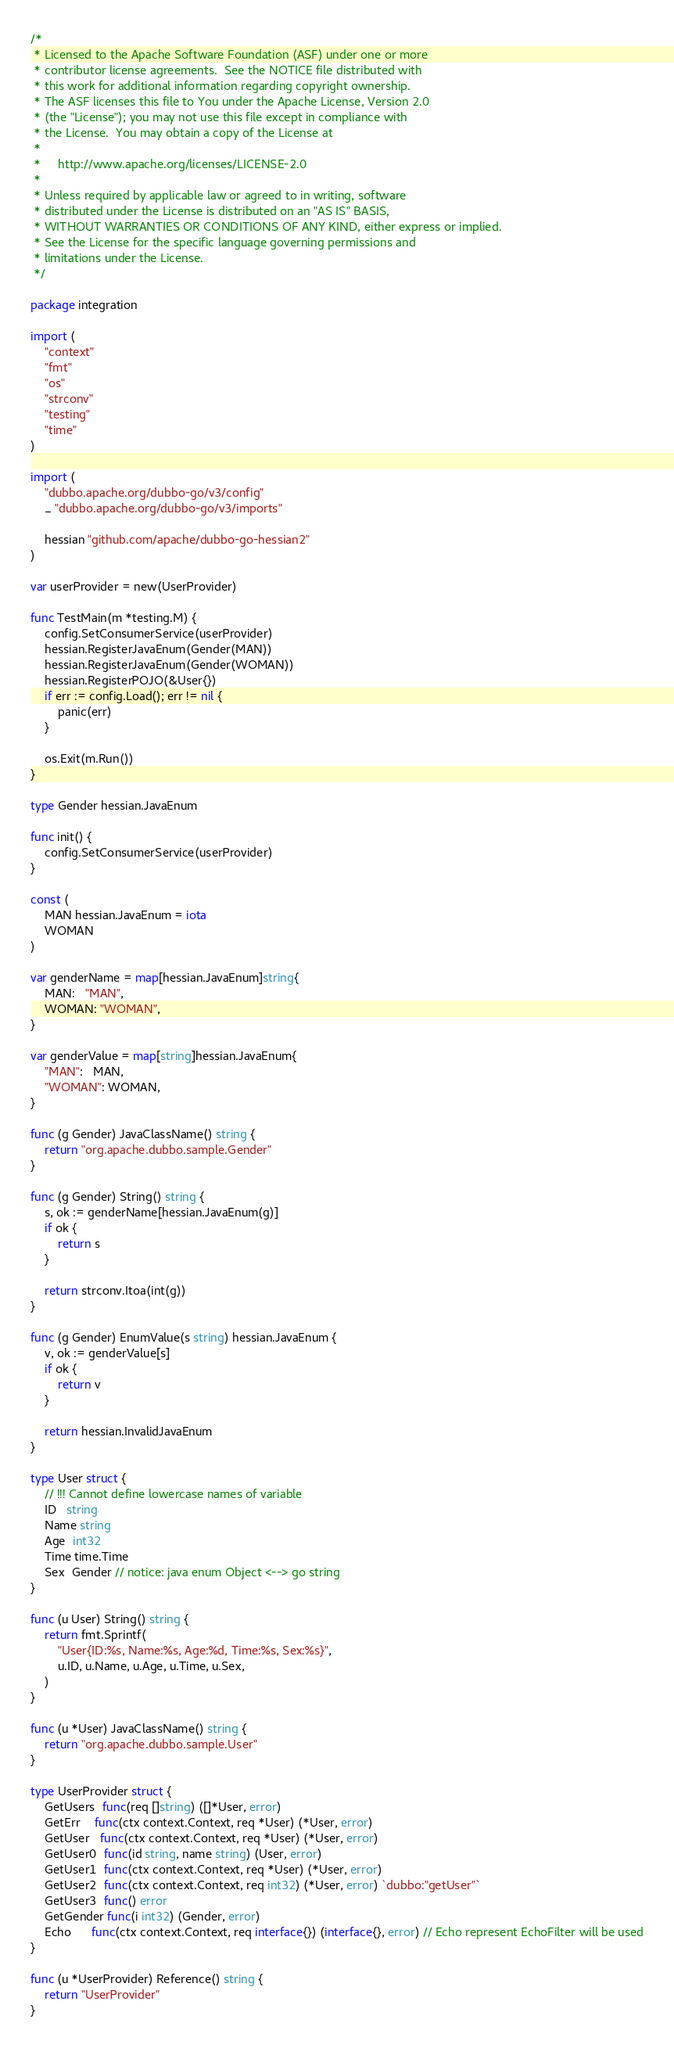Convert code to text. <code><loc_0><loc_0><loc_500><loc_500><_Go_>/*
 * Licensed to the Apache Software Foundation (ASF) under one or more
 * contributor license agreements.  See the NOTICE file distributed with
 * this work for additional information regarding copyright ownership.
 * The ASF licenses this file to You under the Apache License, Version 2.0
 * (the "License"); you may not use this file except in compliance with
 * the License.  You may obtain a copy of the License at
 *
 *     http://www.apache.org/licenses/LICENSE-2.0
 *
 * Unless required by applicable law or agreed to in writing, software
 * distributed under the License is distributed on an "AS IS" BASIS,
 * WITHOUT WARRANTIES OR CONDITIONS OF ANY KIND, either express or implied.
 * See the License for the specific language governing permissions and
 * limitations under the License.
 */

package integration

import (
	"context"
	"fmt"
	"os"
	"strconv"
	"testing"
	"time"
)

import (
	"dubbo.apache.org/dubbo-go/v3/config"
	_ "dubbo.apache.org/dubbo-go/v3/imports"

	hessian "github.com/apache/dubbo-go-hessian2"
)

var userProvider = new(UserProvider)

func TestMain(m *testing.M) {
	config.SetConsumerService(userProvider)
	hessian.RegisterJavaEnum(Gender(MAN))
	hessian.RegisterJavaEnum(Gender(WOMAN))
	hessian.RegisterPOJO(&User{})
	if err := config.Load(); err != nil {
		panic(err)
	}

	os.Exit(m.Run())
}

type Gender hessian.JavaEnum

func init() {
	config.SetConsumerService(userProvider)
}

const (
	MAN hessian.JavaEnum = iota
	WOMAN
)

var genderName = map[hessian.JavaEnum]string{
	MAN:   "MAN",
	WOMAN: "WOMAN",
}

var genderValue = map[string]hessian.JavaEnum{
	"MAN":   MAN,
	"WOMAN": WOMAN,
}

func (g Gender) JavaClassName() string {
	return "org.apache.dubbo.sample.Gender"
}

func (g Gender) String() string {
	s, ok := genderName[hessian.JavaEnum(g)]
	if ok {
		return s
	}

	return strconv.Itoa(int(g))
}

func (g Gender) EnumValue(s string) hessian.JavaEnum {
	v, ok := genderValue[s]
	if ok {
		return v
	}

	return hessian.InvalidJavaEnum
}

type User struct {
	// !!! Cannot define lowercase names of variable
	ID   string
	Name string
	Age  int32
	Time time.Time
	Sex  Gender // notice: java enum Object <--> go string
}

func (u User) String() string {
	return fmt.Sprintf(
		"User{ID:%s, Name:%s, Age:%d, Time:%s, Sex:%s}",
		u.ID, u.Name, u.Age, u.Time, u.Sex,
	)
}

func (u *User) JavaClassName() string {
	return "org.apache.dubbo.sample.User"
}

type UserProvider struct {
	GetUsers  func(req []string) ([]*User, error)
	GetErr    func(ctx context.Context, req *User) (*User, error)
	GetUser   func(ctx context.Context, req *User) (*User, error)
	GetUser0  func(id string, name string) (User, error)
	GetUser1  func(ctx context.Context, req *User) (*User, error)
	GetUser2  func(ctx context.Context, req int32) (*User, error) `dubbo:"getUser"`
	GetUser3  func() error
	GetGender func(i int32) (Gender, error)
	Echo      func(ctx context.Context, req interface{}) (interface{}, error) // Echo represent EchoFilter will be used
}

func (u *UserProvider) Reference() string {
	return "UserProvider"
}
</code> 